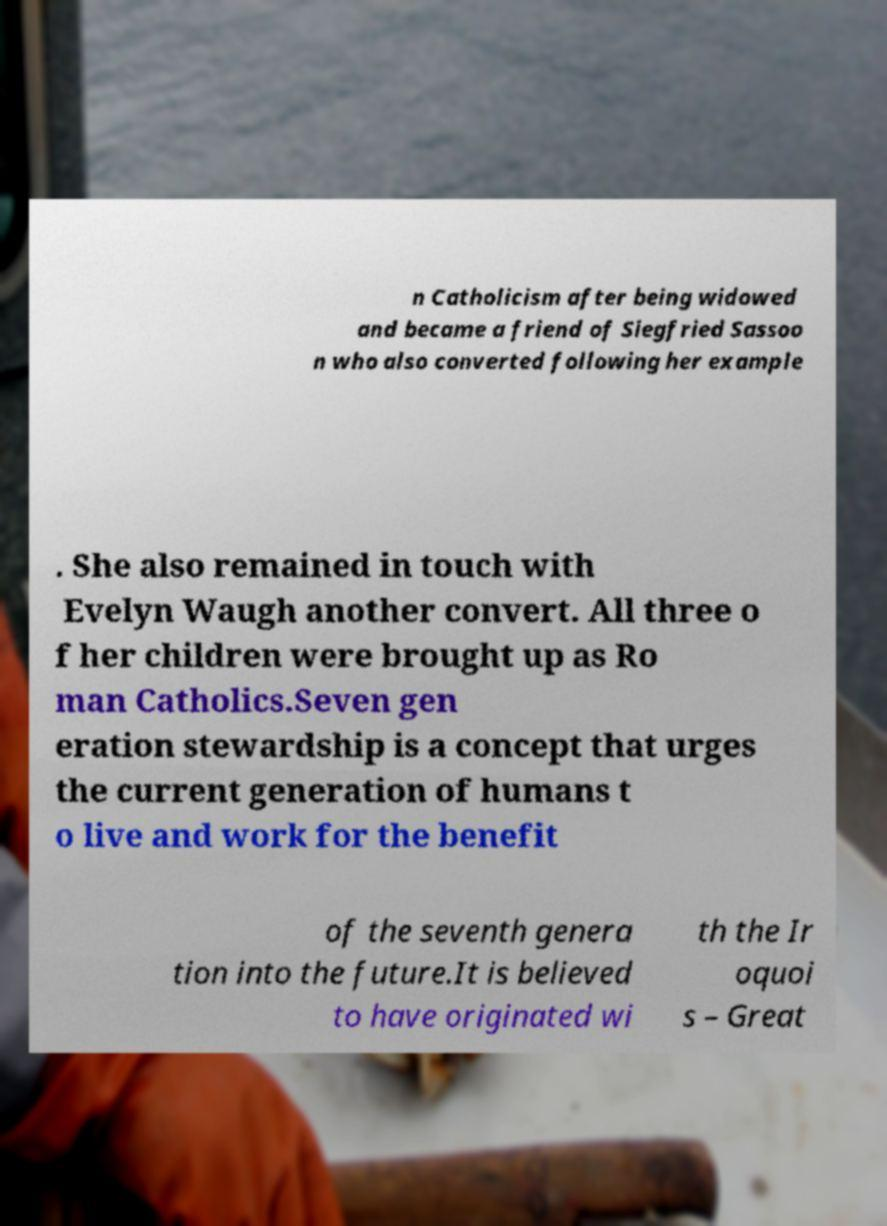Could you extract and type out the text from this image? n Catholicism after being widowed and became a friend of Siegfried Sassoo n who also converted following her example . She also remained in touch with Evelyn Waugh another convert. All three o f her children were brought up as Ro man Catholics.Seven gen eration stewardship is a concept that urges the current generation of humans t o live and work for the benefit of the seventh genera tion into the future.It is believed to have originated wi th the Ir oquoi s – Great 